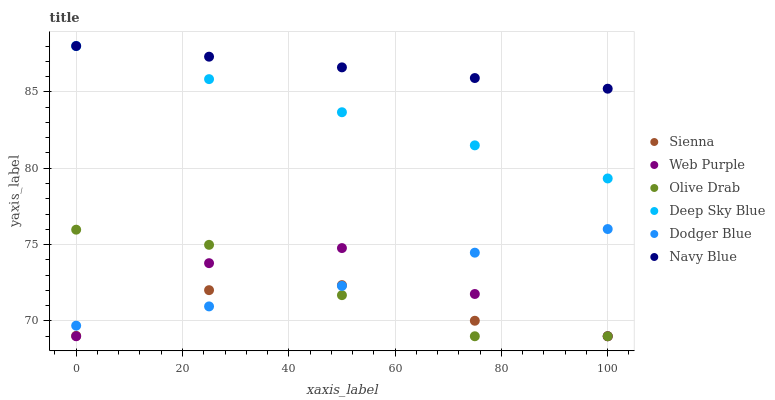Does Sienna have the minimum area under the curve?
Answer yes or no. Yes. Does Navy Blue have the maximum area under the curve?
Answer yes or no. Yes. Does Web Purple have the minimum area under the curve?
Answer yes or no. No. Does Web Purple have the maximum area under the curve?
Answer yes or no. No. Is Navy Blue the smoothest?
Answer yes or no. Yes. Is Web Purple the roughest?
Answer yes or no. Yes. Is Sienna the smoothest?
Answer yes or no. No. Is Sienna the roughest?
Answer yes or no. No. Does Sienna have the lowest value?
Answer yes or no. Yes. Does Dodger Blue have the lowest value?
Answer yes or no. No. Does Deep Sky Blue have the highest value?
Answer yes or no. Yes. Does Web Purple have the highest value?
Answer yes or no. No. Is Web Purple less than Deep Sky Blue?
Answer yes or no. Yes. Is Deep Sky Blue greater than Olive Drab?
Answer yes or no. Yes. Does Web Purple intersect Dodger Blue?
Answer yes or no. Yes. Is Web Purple less than Dodger Blue?
Answer yes or no. No. Is Web Purple greater than Dodger Blue?
Answer yes or no. No. Does Web Purple intersect Deep Sky Blue?
Answer yes or no. No. 